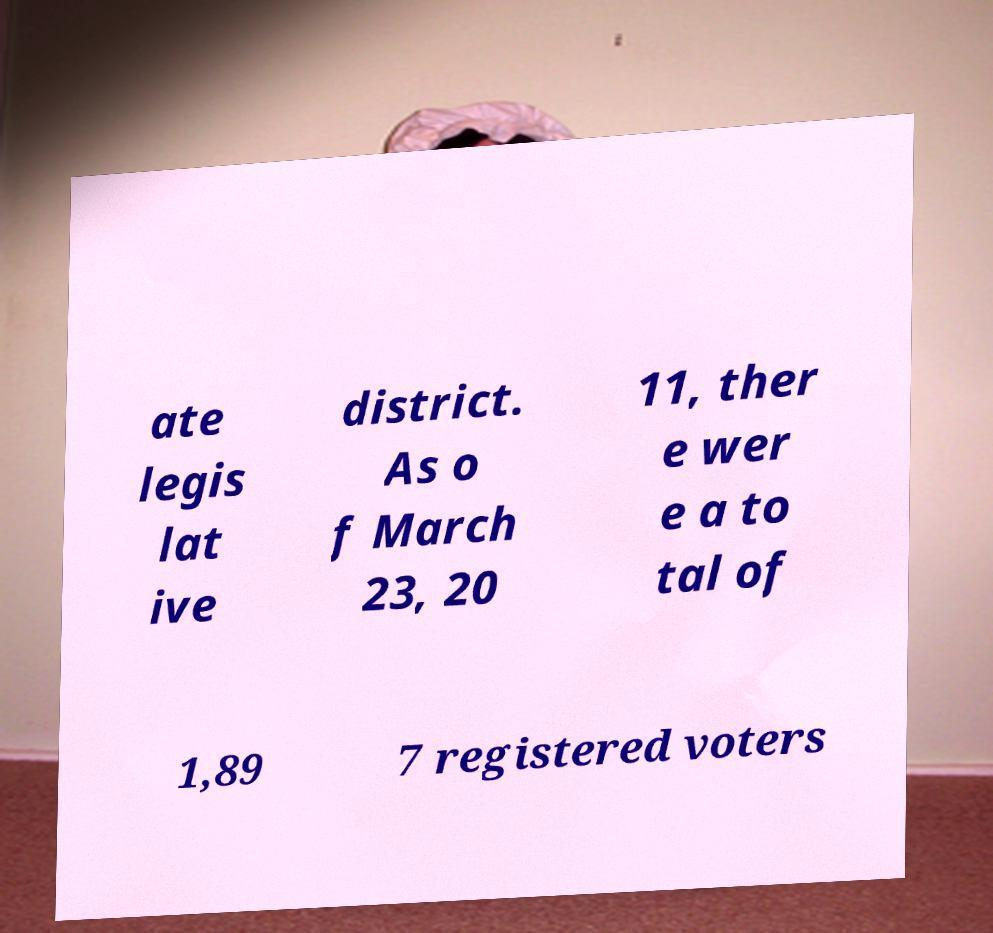Please read and relay the text visible in this image. What does it say? ate legis lat ive district. As o f March 23, 20 11, ther e wer e a to tal of 1,89 7 registered voters 